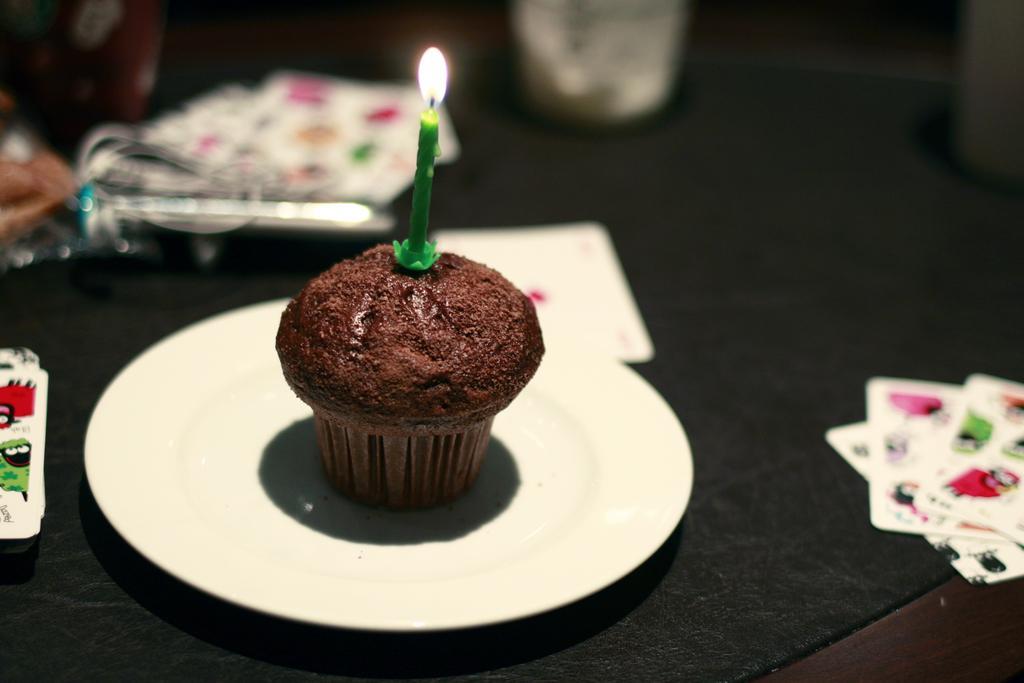Please provide a concise description of this image. In this image I can see a plum cake is on a white color plate. On the plum cake I can see a candle. I can also see cards and other objects on a black color surface. 